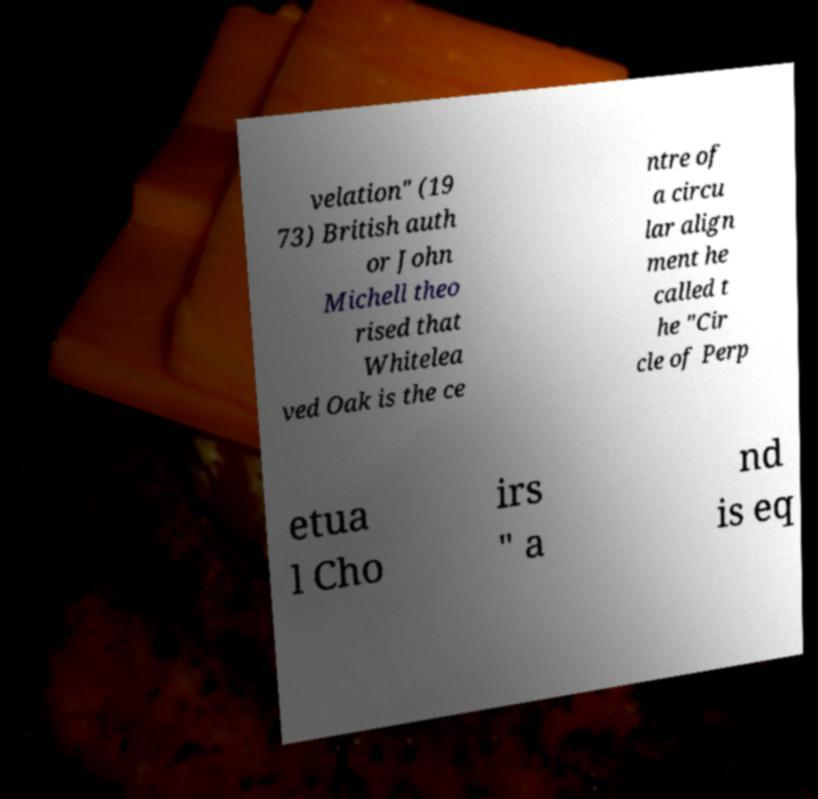Can you accurately transcribe the text from the provided image for me? velation" (19 73) British auth or John Michell theo rised that Whitelea ved Oak is the ce ntre of a circu lar align ment he called t he "Cir cle of Perp etua l Cho irs " a nd is eq 